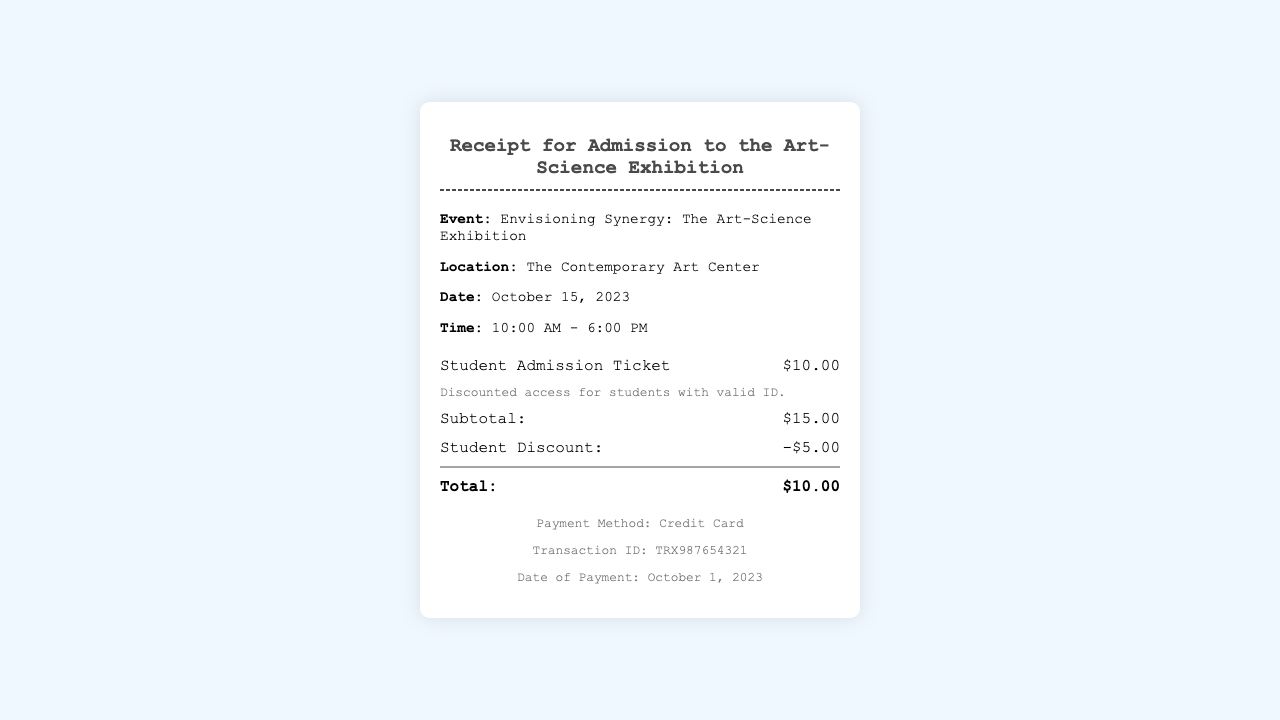What is the title of the exhibition? The title of the exhibition is specified in the document.
Answer: Envisioning Synergy: The Art-Science Exhibition What is the location of the event? The location is mentioned in the event details of the document.
Answer: The Contemporary Art Center What is the date of the exhibition? The document provides the specific date when the event takes place.
Answer: October 15, 2023 What is the cost of the Student Admission Ticket? The cost is listed alongside the ticket item in the receipt.
Answer: $10.00 What discount is applied for students? The document states the discount given for student tickets.
Answer: -$5.00 What is the total amount paid for the ticket? The total amount is calculated and displayed at the bottom of the receipt.
Answer: $10.00 How was the payment made? The method of payment is mentioned in the payment information section.
Answer: Credit Card What is the Transaction ID? The Transaction ID is provided in the payment information part of the document.
Answer: TRX987654321 At what time does the exhibition start? The start time of the exhibition is included in the event details.
Answer: 10:00 AM What is the subtotal before any discounts? The subtotal is listed prior to the application of discounts in the document.
Answer: $15.00 